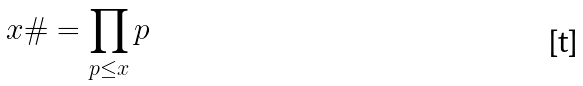<formula> <loc_0><loc_0><loc_500><loc_500>x \# = \prod _ { p \leq x } p</formula> 